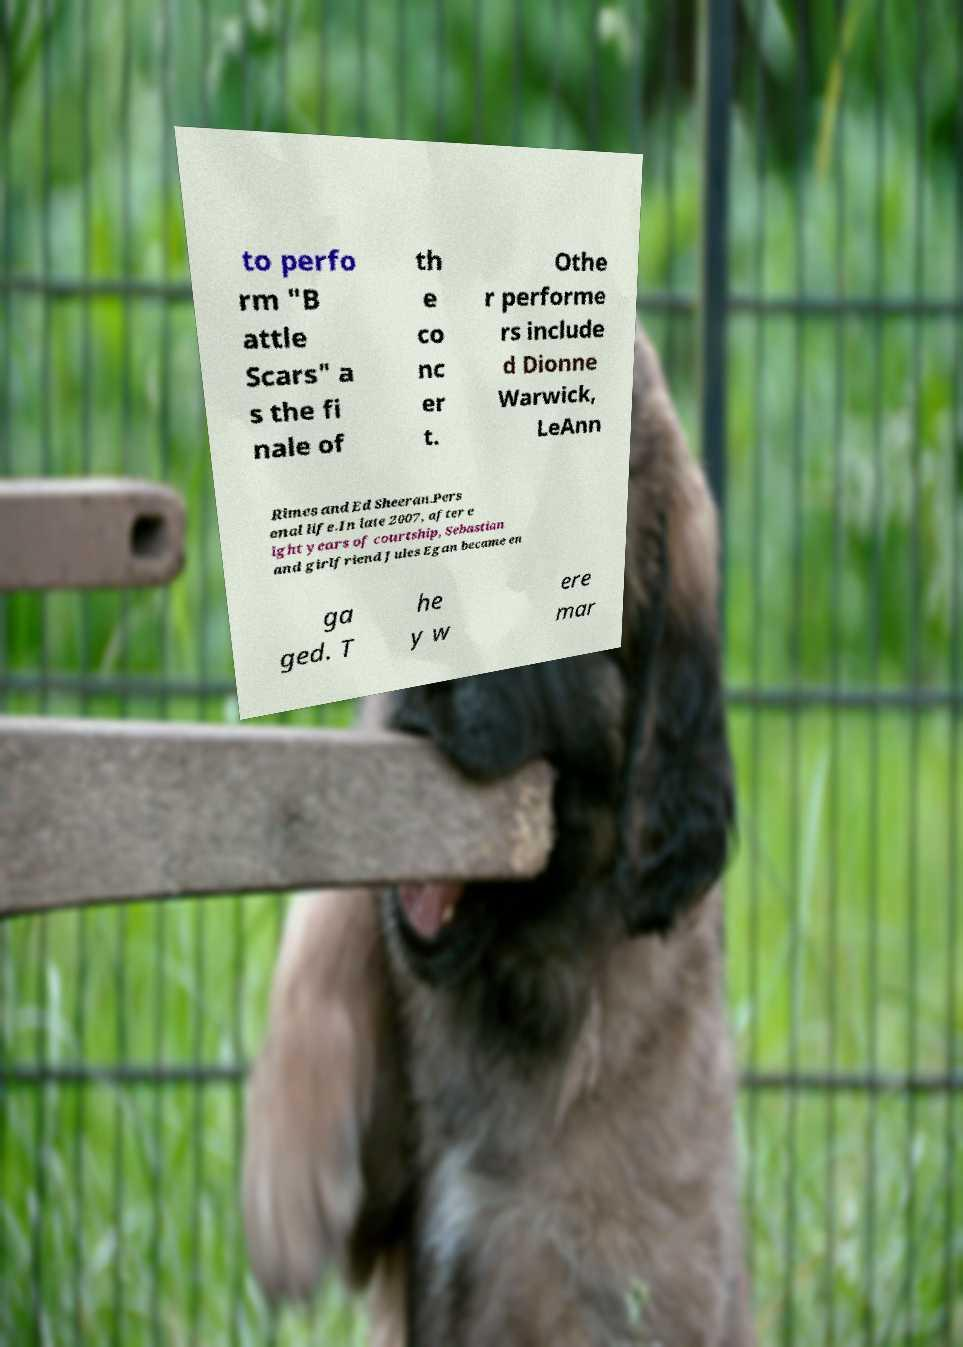There's text embedded in this image that I need extracted. Can you transcribe it verbatim? to perfo rm "B attle Scars" a s the fi nale of th e co nc er t. Othe r performe rs include d Dionne Warwick, LeAnn Rimes and Ed Sheeran.Pers onal life.In late 2007, after e ight years of courtship, Sebastian and girlfriend Jules Egan became en ga ged. T he y w ere mar 